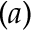Convert formula to latex. <formula><loc_0><loc_0><loc_500><loc_500>( a )</formula> 